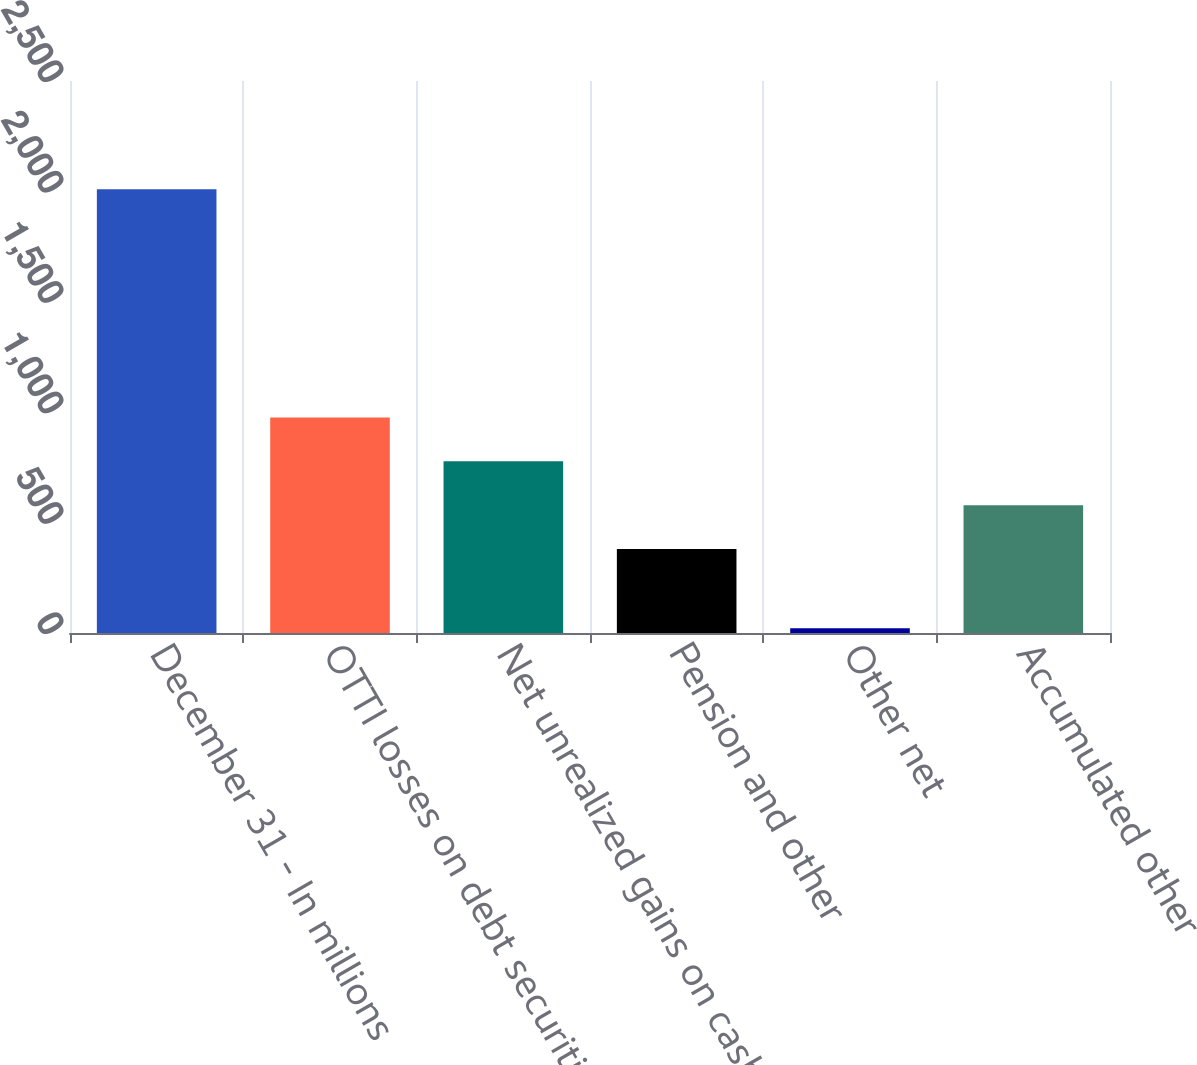Convert chart to OTSL. <chart><loc_0><loc_0><loc_500><loc_500><bar_chart><fcel>December 31 - In millions<fcel>OTTI losses on debt securities<fcel>Net unrealized gains on cash<fcel>Pension and other<fcel>Other net<fcel>Accumulated other<nl><fcel>2010<fcel>976.4<fcel>777.6<fcel>380<fcel>22<fcel>578.8<nl></chart> 